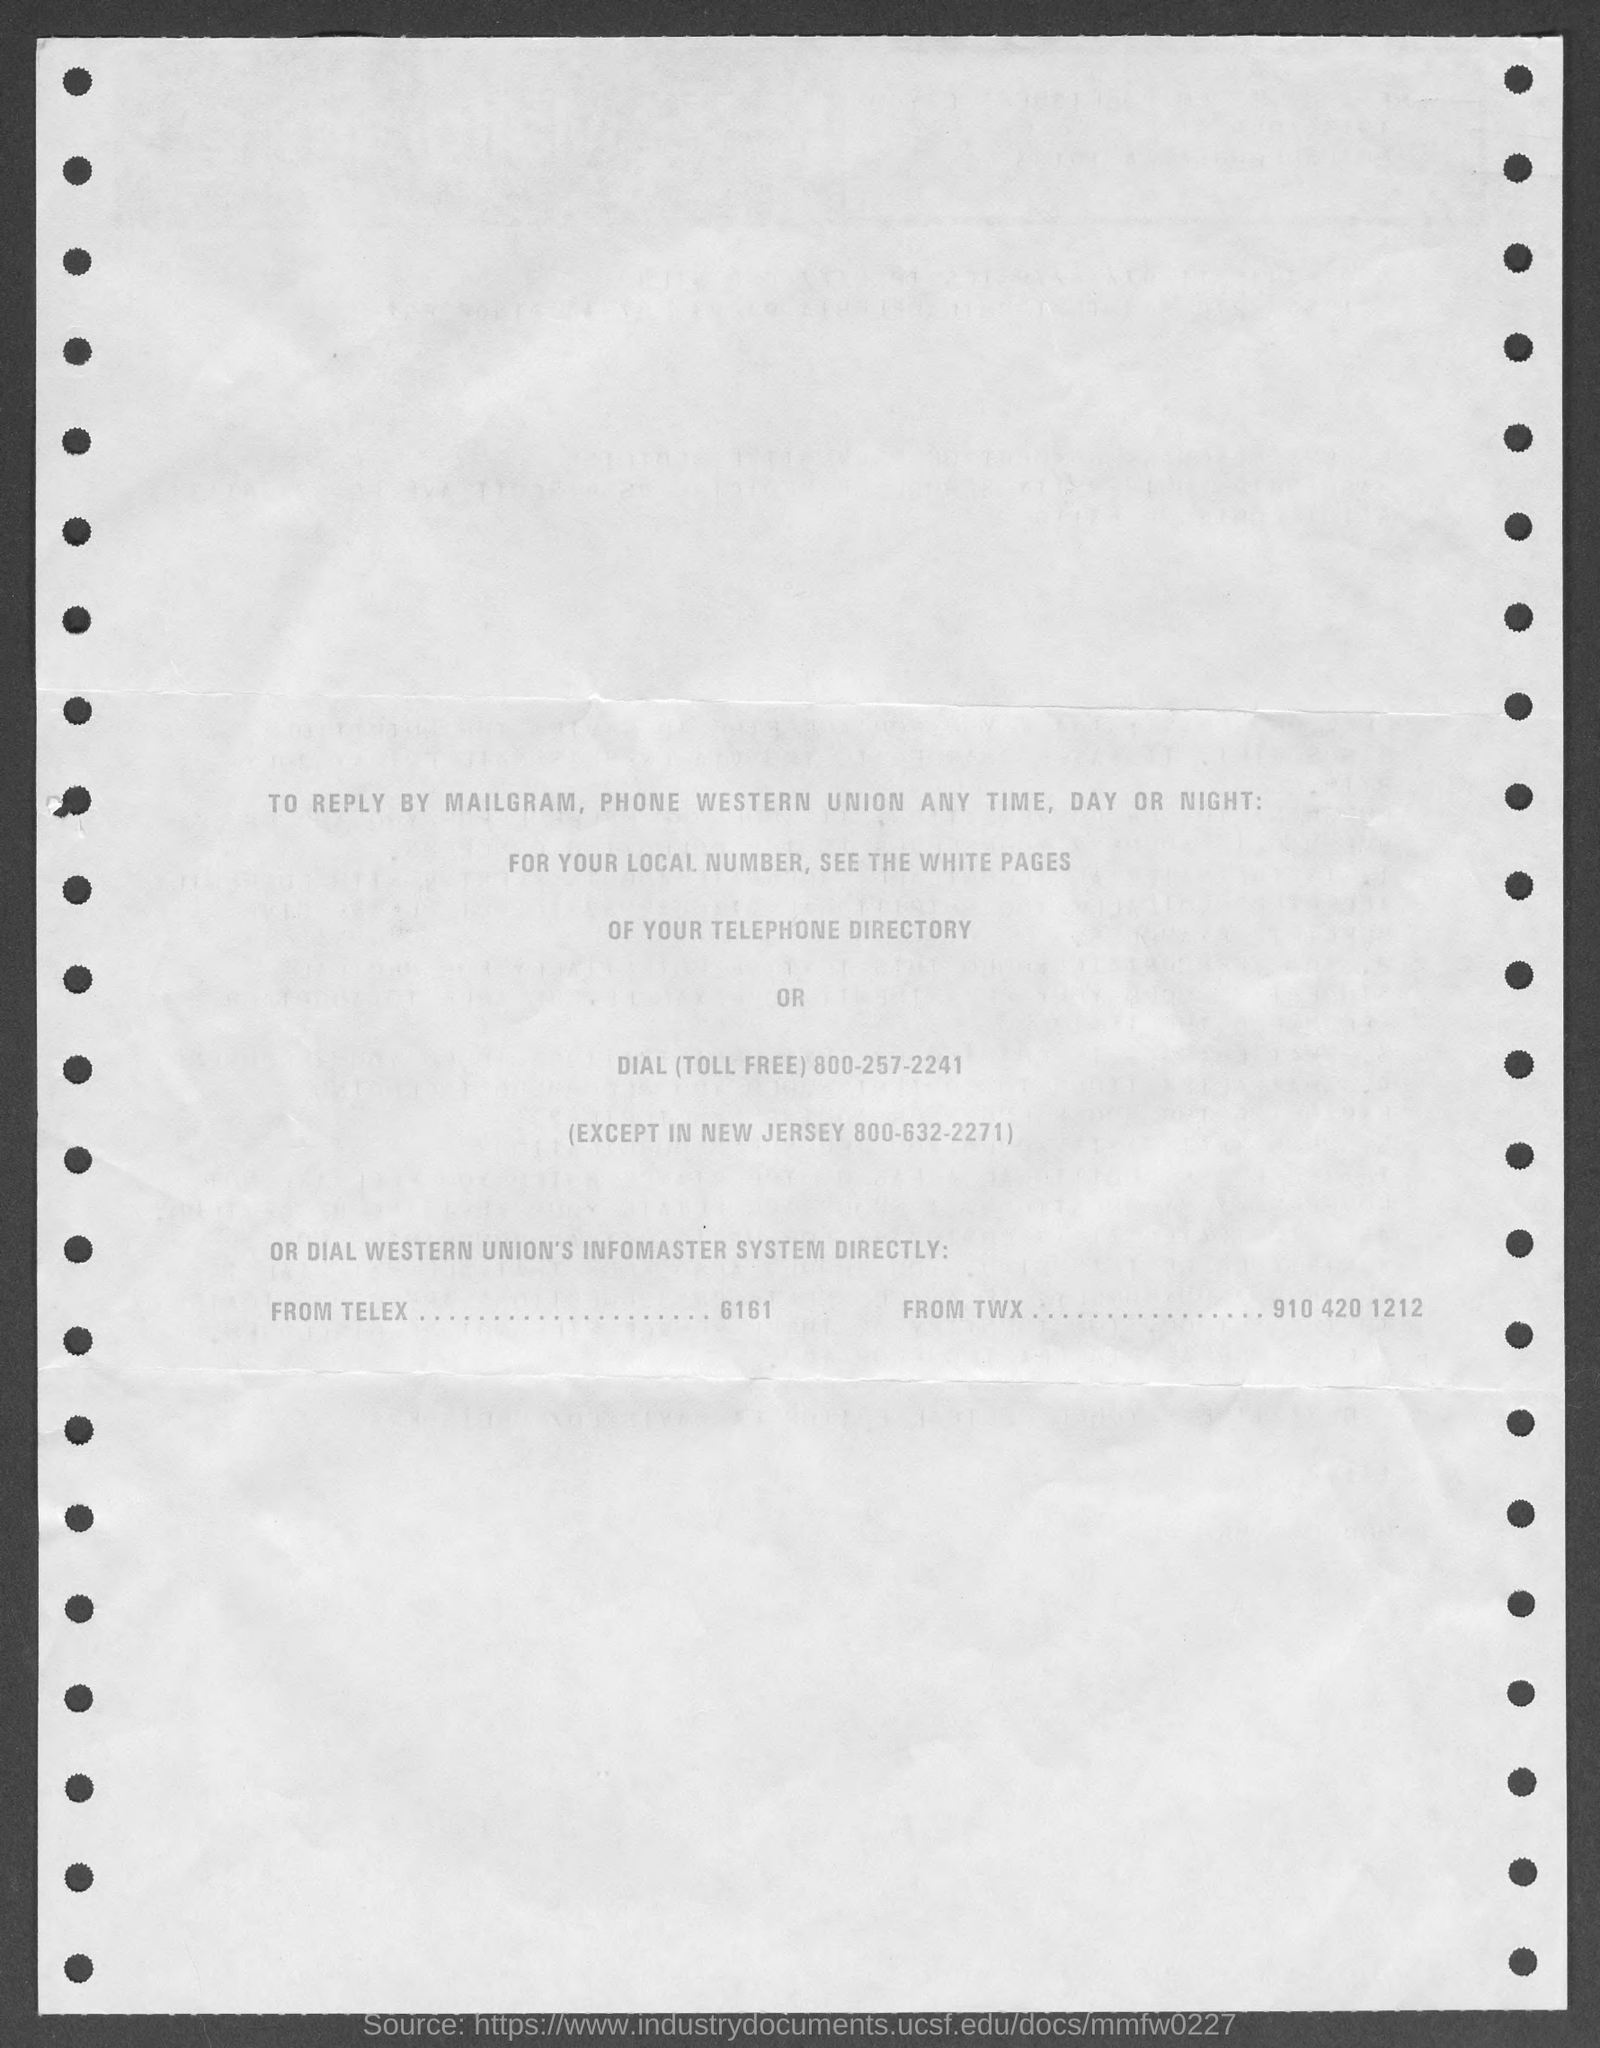What is the toll free number mentioned?
Your response must be concise. 800-257-2241. What is the number for new jersey?
Your answer should be compact. 800-632-2271. Where to find the local numbers?
Provide a short and direct response. For your local number, see the white pages of your telephone directory. 